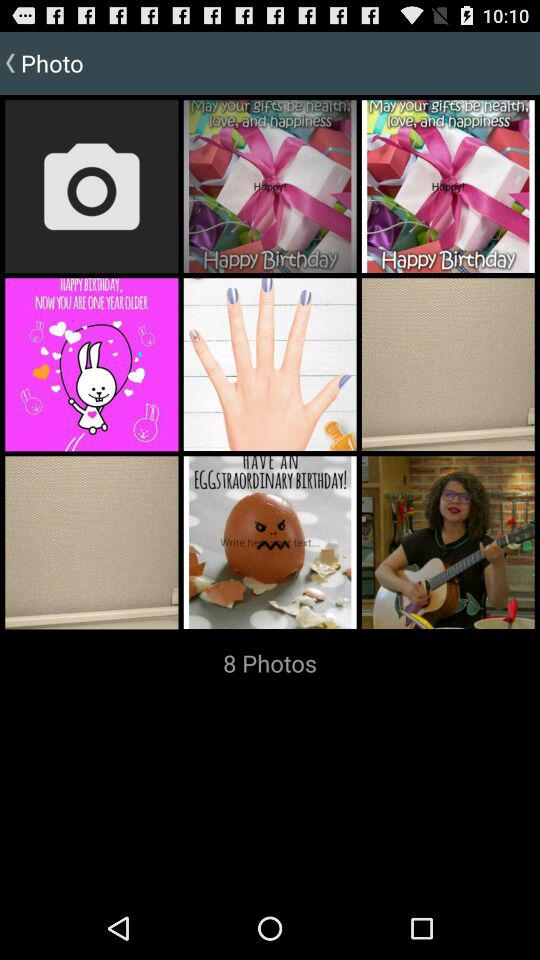How many photos are in the album?
Answer the question using a single word or phrase. 8 